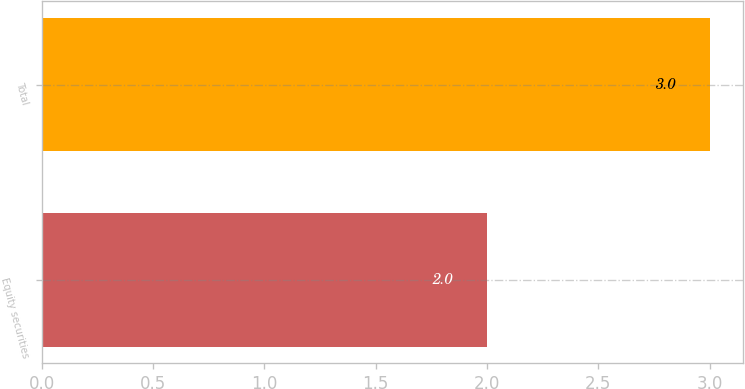<chart> <loc_0><loc_0><loc_500><loc_500><bar_chart><fcel>Equity securities<fcel>Total<nl><fcel>2<fcel>3<nl></chart> 